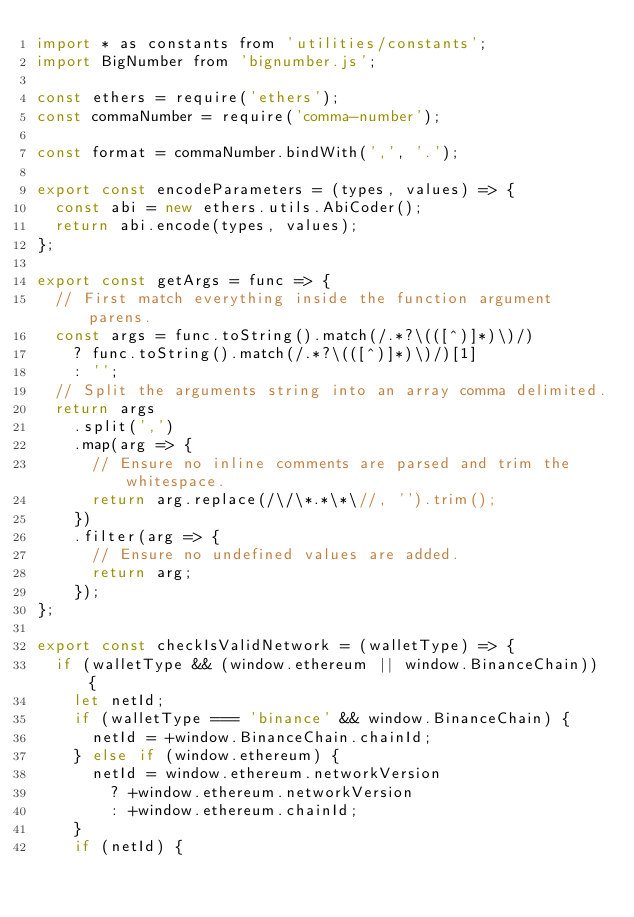Convert code to text. <code><loc_0><loc_0><loc_500><loc_500><_JavaScript_>import * as constants from 'utilities/constants';
import BigNumber from 'bignumber.js';

const ethers = require('ethers');
const commaNumber = require('comma-number');

const format = commaNumber.bindWith(',', '.');

export const encodeParameters = (types, values) => {
  const abi = new ethers.utils.AbiCoder();
  return abi.encode(types, values);
};

export const getArgs = func => {
  // First match everything inside the function argument parens.
  const args = func.toString().match(/.*?\(([^)]*)\)/)
    ? func.toString().match(/.*?\(([^)]*)\)/)[1]
    : '';
  // Split the arguments string into an array comma delimited.
  return args
    .split(',')
    .map(arg => {
      // Ensure no inline comments are parsed and trim the whitespace.
      return arg.replace(/\/\*.*\*\//, '').trim();
    })
    .filter(arg => {
      // Ensure no undefined values are added.
      return arg;
    });
};

export const checkIsValidNetwork = (walletType) => {
  if (walletType && (window.ethereum || window.BinanceChain)) {
    let netId;
    if (walletType === 'binance' && window.BinanceChain) {
      netId = +window.BinanceChain.chainId;
    } else if (window.ethereum) {
      netId = window.ethereum.networkVersion
        ? +window.ethereum.networkVersion
        : +window.ethereum.chainId;
    }
    if (netId) {</code> 